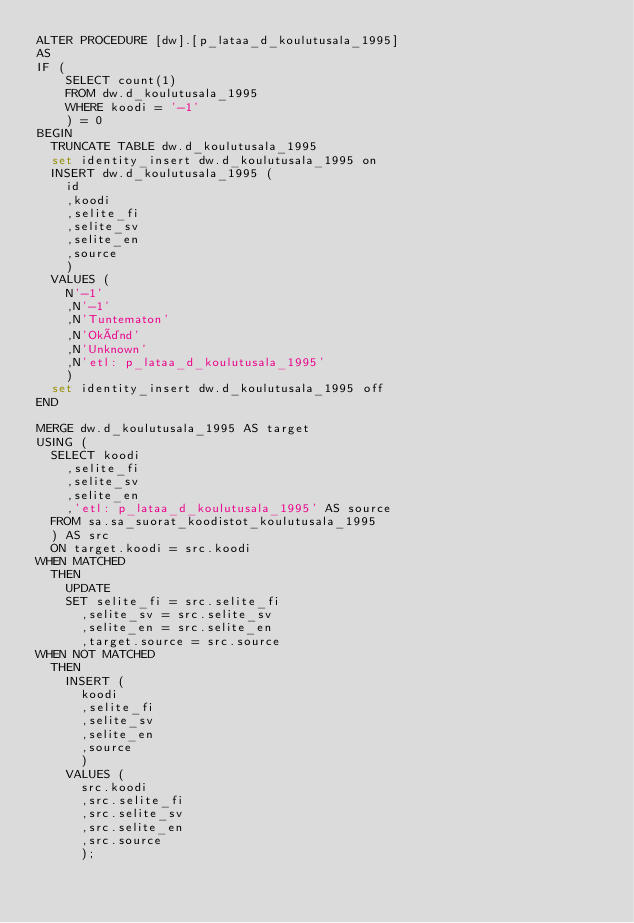Convert code to text. <code><loc_0><loc_0><loc_500><loc_500><_SQL_>ALTER PROCEDURE [dw].[p_lataa_d_koulutusala_1995]
AS
IF (
		SELECT count(1)
		FROM dw.d_koulutusala_1995
		WHERE koodi = '-1'
		) = 0
BEGIN
	TRUNCATE TABLE dw.d_koulutusala_1995
	set identity_insert dw.d_koulutusala_1995 on	
	INSERT dw.d_koulutusala_1995 (
		id
		,koodi
		,selite_fi
		,selite_sv
		,selite_en
		,source
		)
	VALUES (
		N'-1'
		,N'-1'
		,N'Tuntematon'
		,N'Okänd'
		,N'Unknown'
		,N'etl: p_lataa_d_koulutusala_1995'
		)
	set identity_insert dw.d_koulutusala_1995 off	
END

MERGE dw.d_koulutusala_1995 AS target
USING (
	SELECT koodi
		,selite_fi
		,selite_sv
		,selite_en
		,'etl: p_lataa_d_koulutusala_1995' AS source
	FROM sa.sa_suorat_koodistot_koulutusala_1995
	) AS src
	ON target.koodi = src.koodi
WHEN MATCHED
	THEN
		UPDATE
		SET selite_fi = src.selite_fi
			,selite_sv = src.selite_sv
			,selite_en = src.selite_en
			,target.source = src.source
WHEN NOT MATCHED
	THEN
		INSERT (
			koodi
			,selite_fi
			,selite_sv
			,selite_en
			,source
			)
		VALUES (
			src.koodi
			,src.selite_fi
			,src.selite_sv
			,src.selite_en
			,src.source
			);</code> 